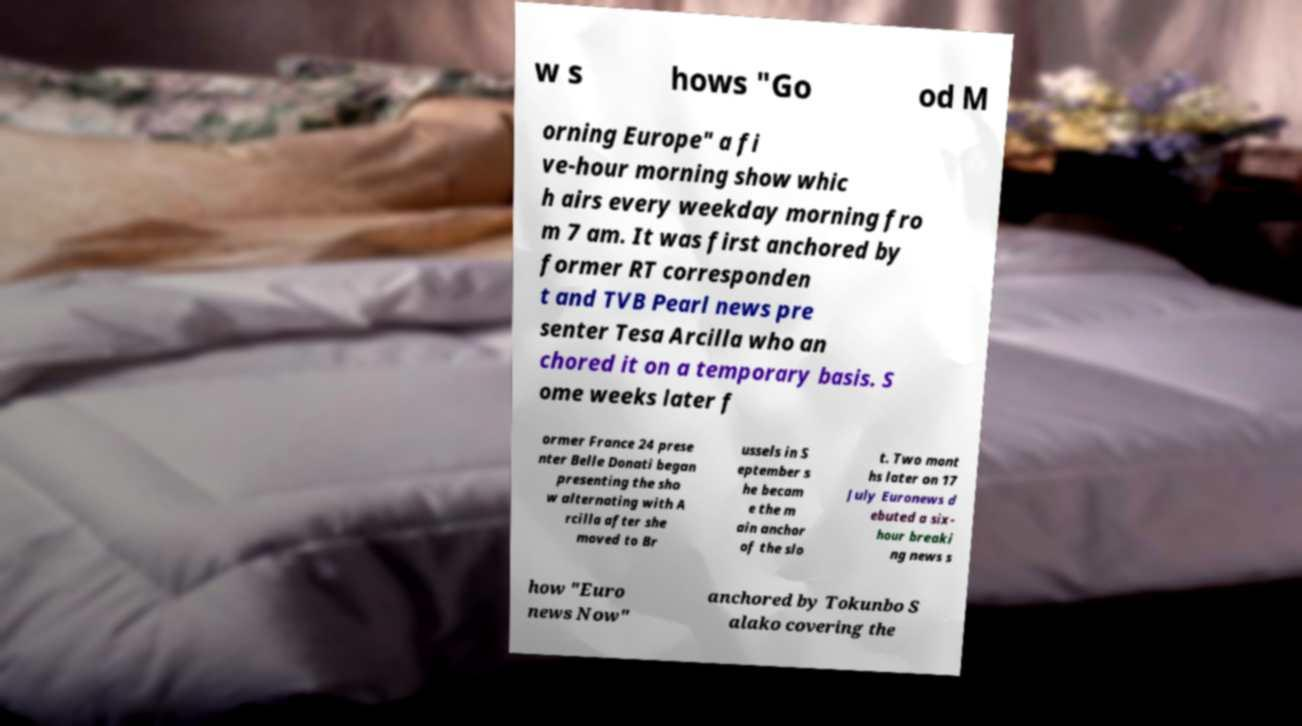Can you read and provide the text displayed in the image?This photo seems to have some interesting text. Can you extract and type it out for me? w s hows "Go od M orning Europe" a fi ve-hour morning show whic h airs every weekday morning fro m 7 am. It was first anchored by former RT corresponden t and TVB Pearl news pre senter Tesa Arcilla who an chored it on a temporary basis. S ome weeks later f ormer France 24 prese nter Belle Donati began presenting the sho w alternating with A rcilla after she moved to Br ussels in S eptember s he becam e the m ain anchor of the slo t. Two mont hs later on 17 July Euronews d ebuted a six- hour breaki ng news s how "Euro news Now" anchored by Tokunbo S alako covering the 